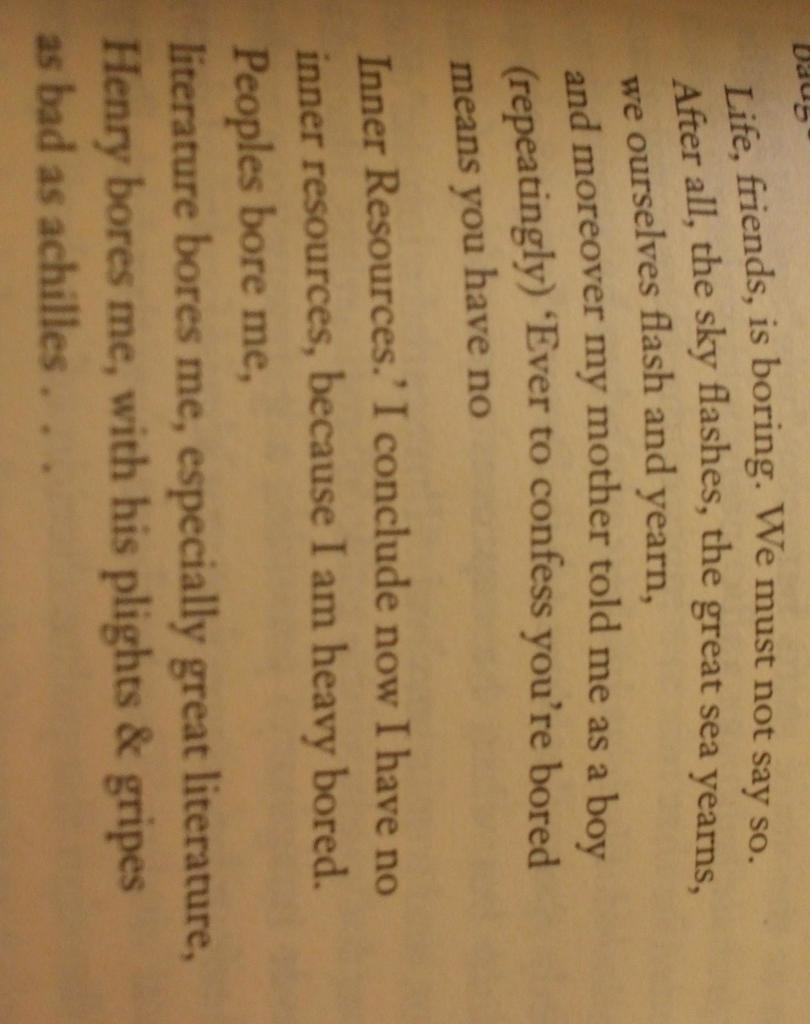Provide a one-sentence caption for the provided image. an excerpt of a book featuring characters like achilles and henry. 